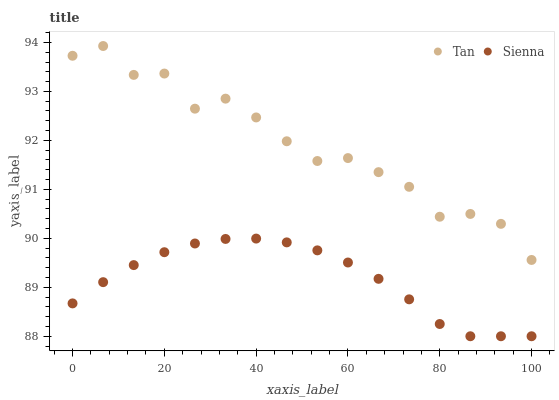Does Sienna have the minimum area under the curve?
Answer yes or no. Yes. Does Tan have the maximum area under the curve?
Answer yes or no. Yes. Does Tan have the minimum area under the curve?
Answer yes or no. No. Is Sienna the smoothest?
Answer yes or no. Yes. Is Tan the roughest?
Answer yes or no. Yes. Is Tan the smoothest?
Answer yes or no. No. Does Sienna have the lowest value?
Answer yes or no. Yes. Does Tan have the lowest value?
Answer yes or no. No. Does Tan have the highest value?
Answer yes or no. Yes. Is Sienna less than Tan?
Answer yes or no. Yes. Is Tan greater than Sienna?
Answer yes or no. Yes. Does Sienna intersect Tan?
Answer yes or no. No. 